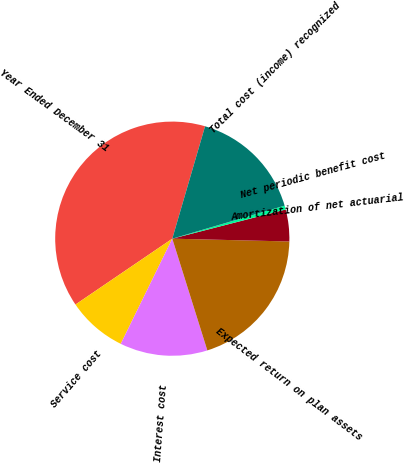Convert chart. <chart><loc_0><loc_0><loc_500><loc_500><pie_chart><fcel>Year Ended December 31<fcel>Service cost<fcel>Interest cost<fcel>Expected return on plan assets<fcel>Amortization of net actuarial<fcel>Net periodic benefit cost<fcel>Total cost (income) recognized<nl><fcel>39.02%<fcel>8.24%<fcel>12.09%<fcel>19.78%<fcel>4.39%<fcel>0.54%<fcel>15.93%<nl></chart> 